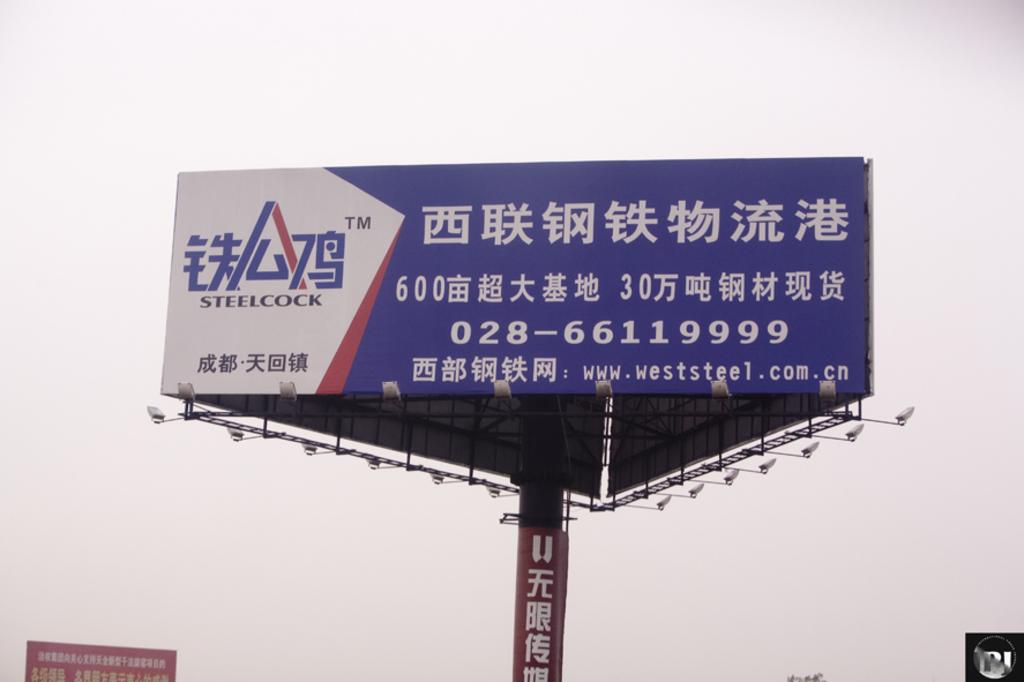What brand is this advertisement for?
Provide a short and direct response. Steelcock. What is the phone number on the billboard?
Ensure brevity in your answer.  028-66119999. 